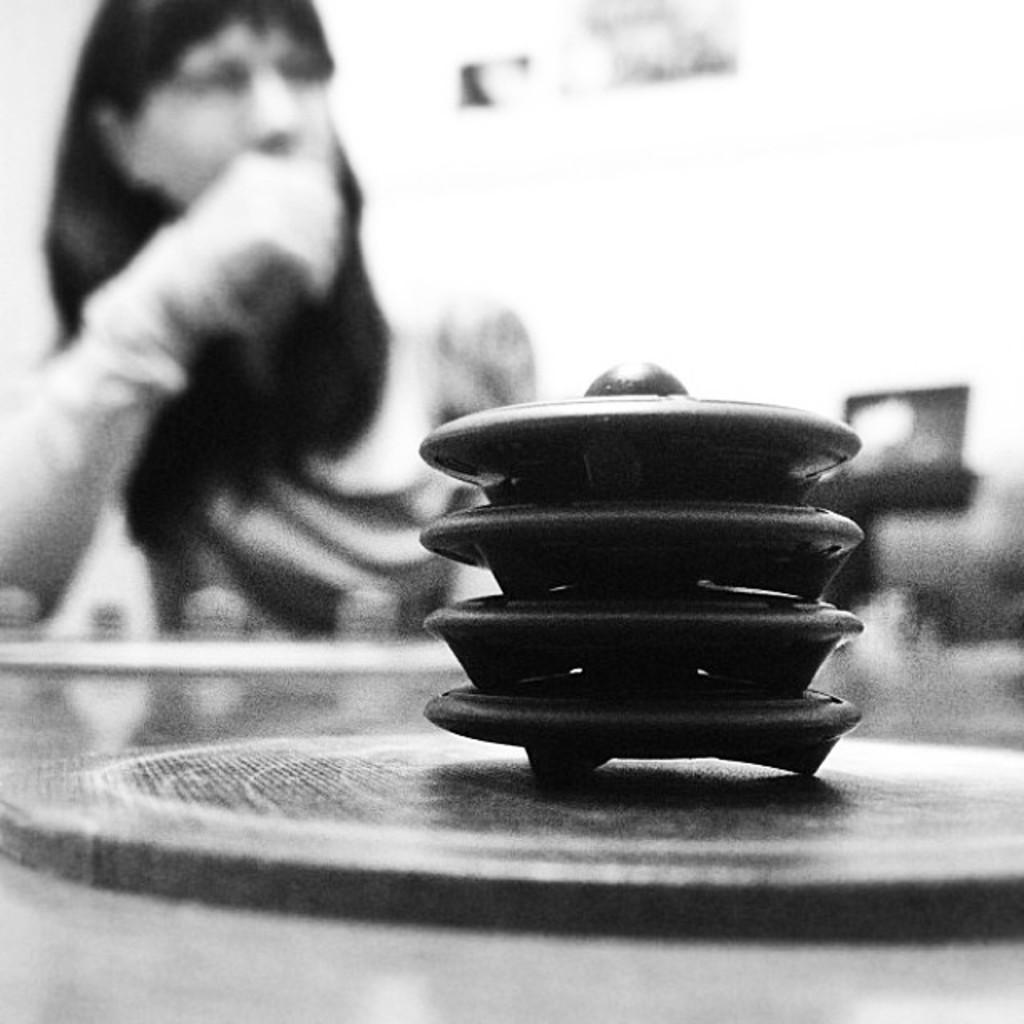Could you give a brief overview of what you see in this image? This is a black and white image. These are the kind of kids, which are placed one on the other. This looks like a table. In the background, I can see the woman sitting. 